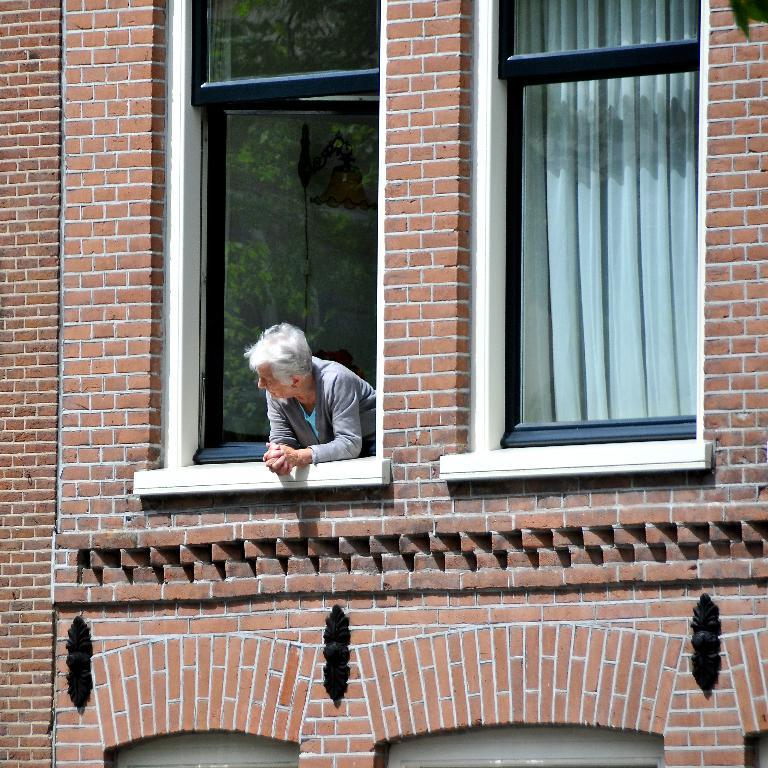What type of structure is visible in the image? There is a building in the image. What feature can be seen on the building? The building has windows. What is present near the windows? There is a curtain in the image. Can you describe the person in the image? There is a person standing in the image. What type of soda is the person holding in the image? There is no soda present in the image; the person is not holding any beverage. What color is the ink used to write on the curtain in the image? There is no writing or ink present on the curtain in the image. 